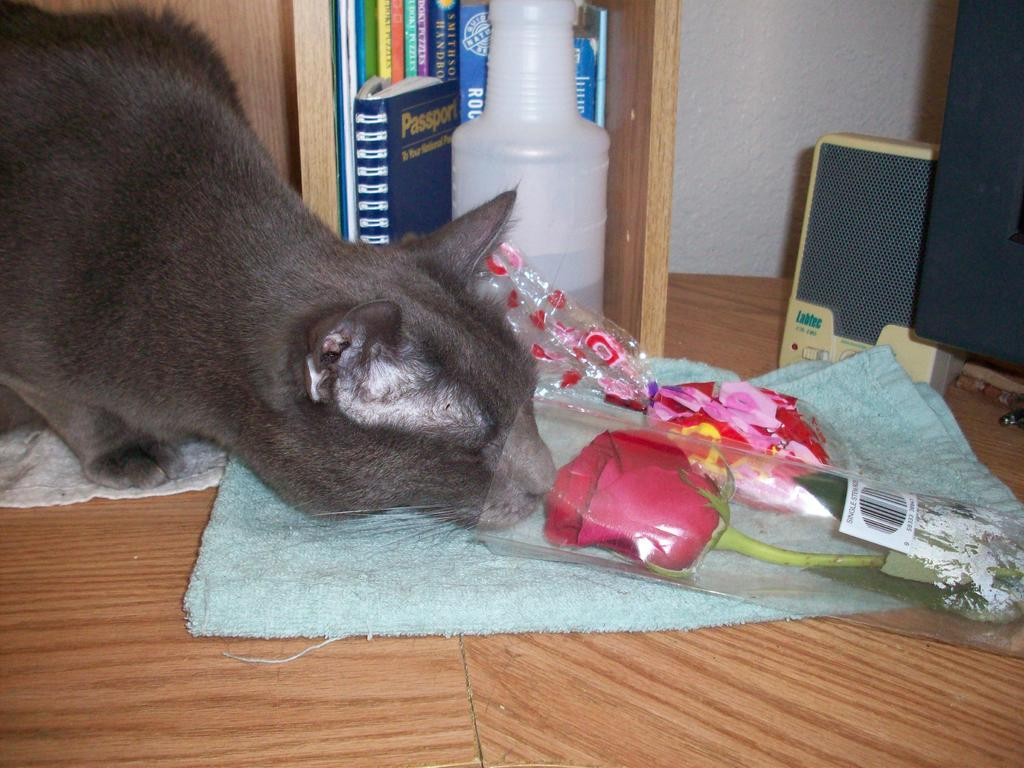What type of animal can be seen in the image? There is a gray cat in the image. What surface is visible in the image? The image shows a floor. What is the flower in the image wrapped in? The flower is wrapped in a cover in the image. What type of items are present in the image? Books are present in the image. What device is visible in the image? A sound box is visible in the image. What object is in the image? There is an object in the image. What item might be used for cleaning or wiping in the image? A napkin is present in the image. What color is the orange in the image? There is no orange present in the image. How many children are visible in the image? There are no children visible in the image. 